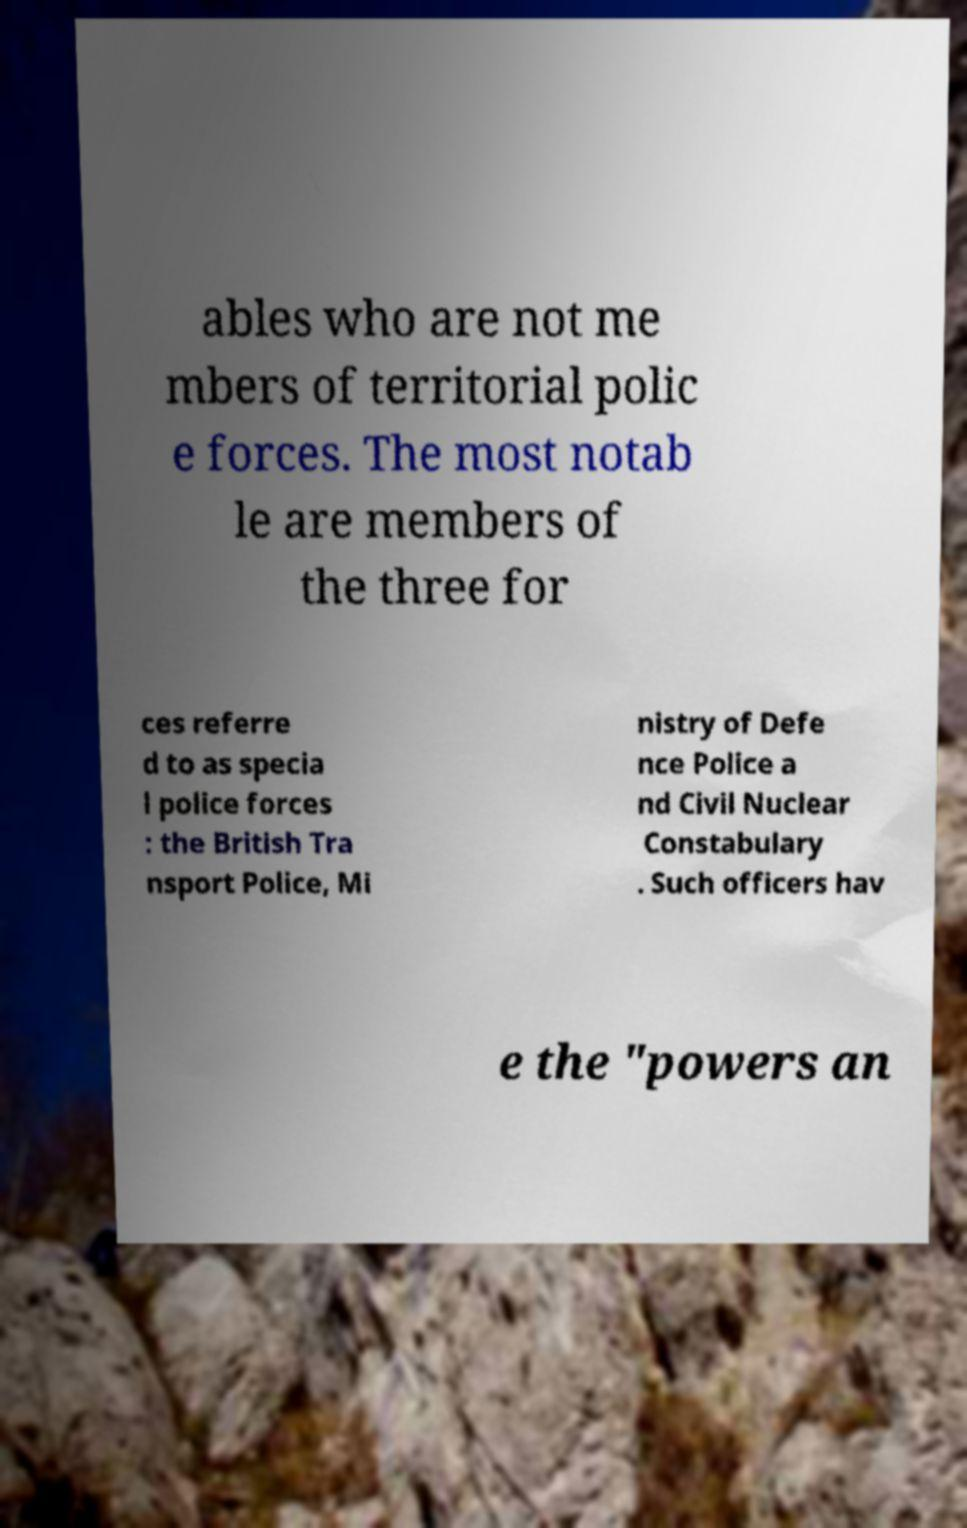Can you read and provide the text displayed in the image?This photo seems to have some interesting text. Can you extract and type it out for me? ables who are not me mbers of territorial polic e forces. The most notab le are members of the three for ces referre d to as specia l police forces : the British Tra nsport Police, Mi nistry of Defe nce Police a nd Civil Nuclear Constabulary . Such officers hav e the "powers an 